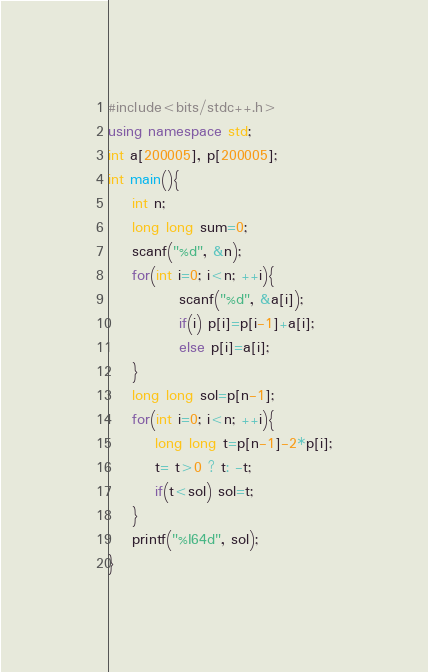Convert code to text. <code><loc_0><loc_0><loc_500><loc_500><_C++_>#include<bits/stdc++.h>
using namespace std;
int a[200005], p[200005];
int main(){
    int n;
    long long sum=0;
    scanf("%d", &n);
    for(int i=0; i<n; ++i){
            scanf("%d", &a[i]);
            if(i) p[i]=p[i-1]+a[i];
            else p[i]=a[i];
    }
    long long sol=p[n-1];
    for(int i=0; i<n; ++i){
        long long t=p[n-1]-2*p[i];
        t= t>0 ? t: -t;
        if(t<sol) sol=t;
    }
    printf("%I64d", sol);
}</code> 